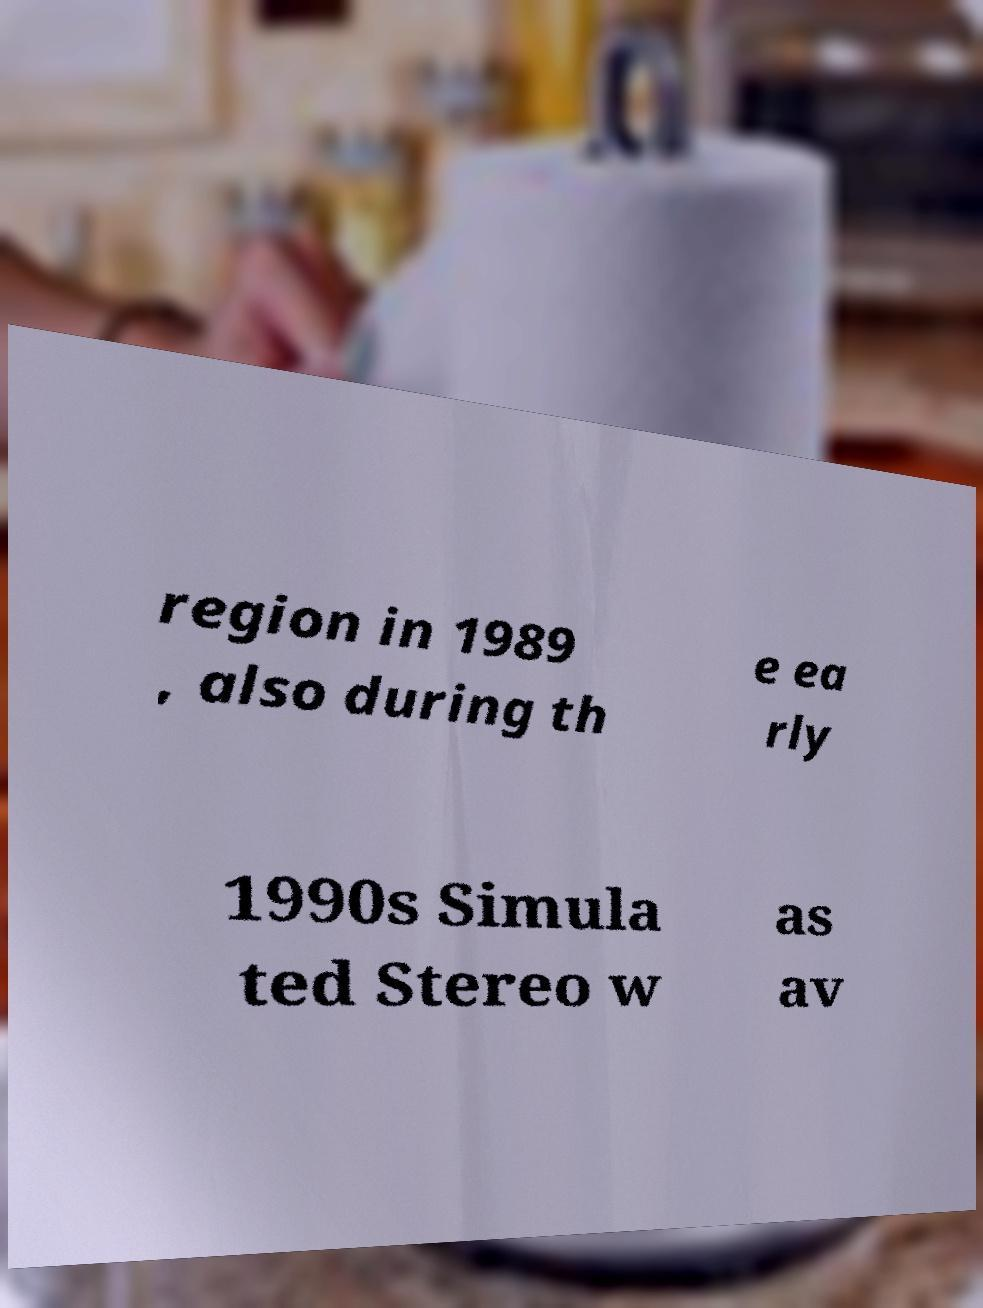Please read and relay the text visible in this image. What does it say? region in 1989 , also during th e ea rly 1990s Simula ted Stereo w as av 